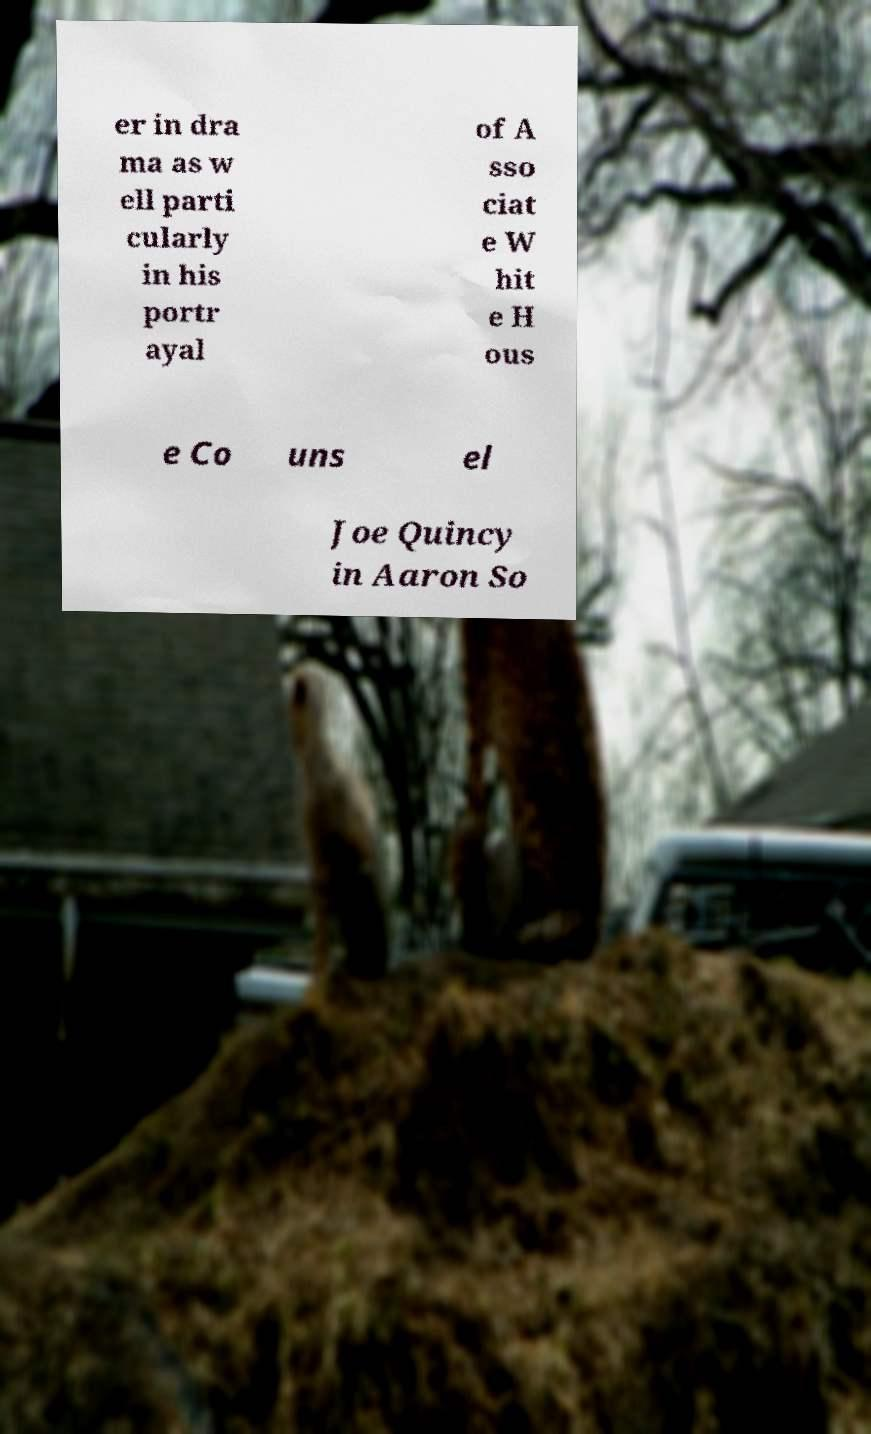Can you read and provide the text displayed in the image?This photo seems to have some interesting text. Can you extract and type it out for me? er in dra ma as w ell parti cularly in his portr ayal of A sso ciat e W hit e H ous e Co uns el Joe Quincy in Aaron So 